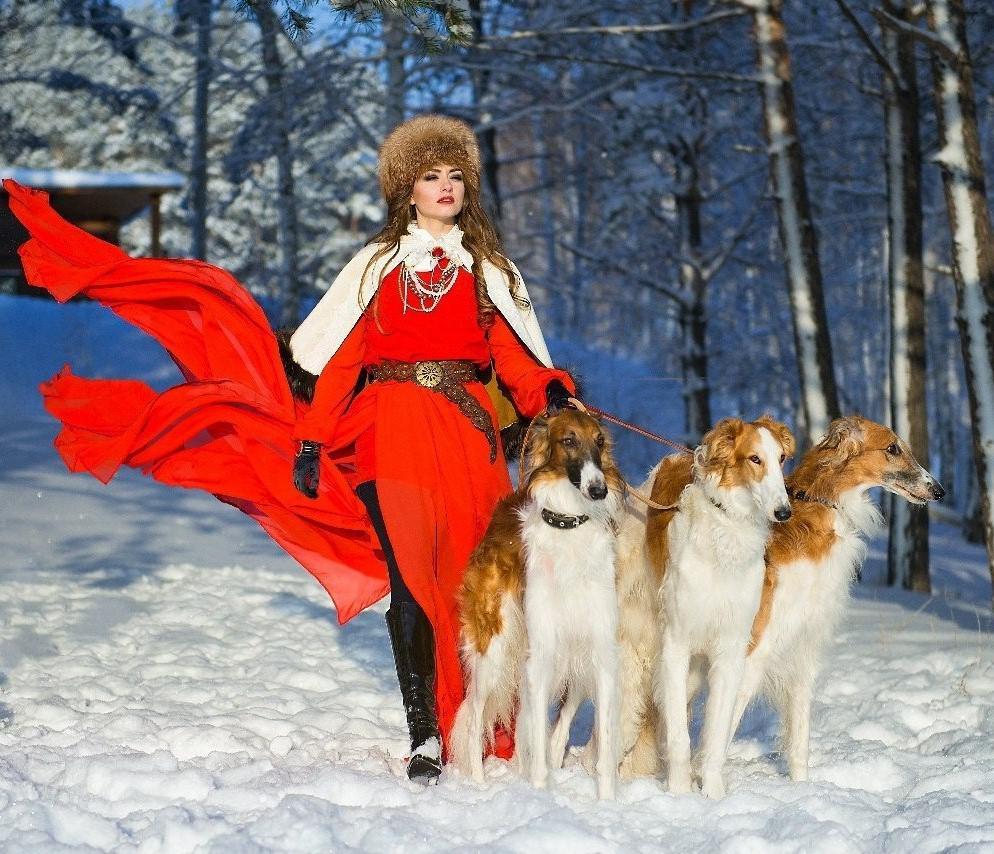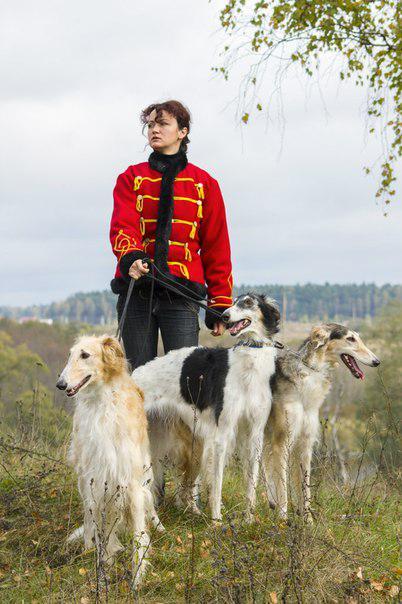The first image is the image on the left, the second image is the image on the right. Evaluate the accuracy of this statement regarding the images: "In image there is a woman dressed in red walking three Russian Wolfhounds in the snow.". Is it true? Answer yes or no. Yes. 